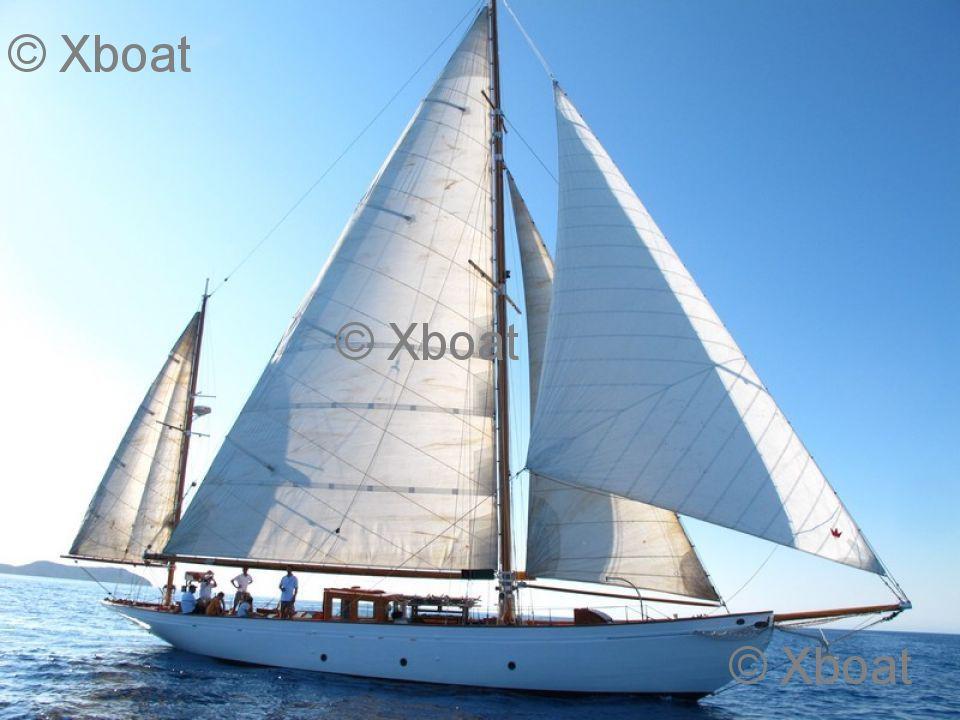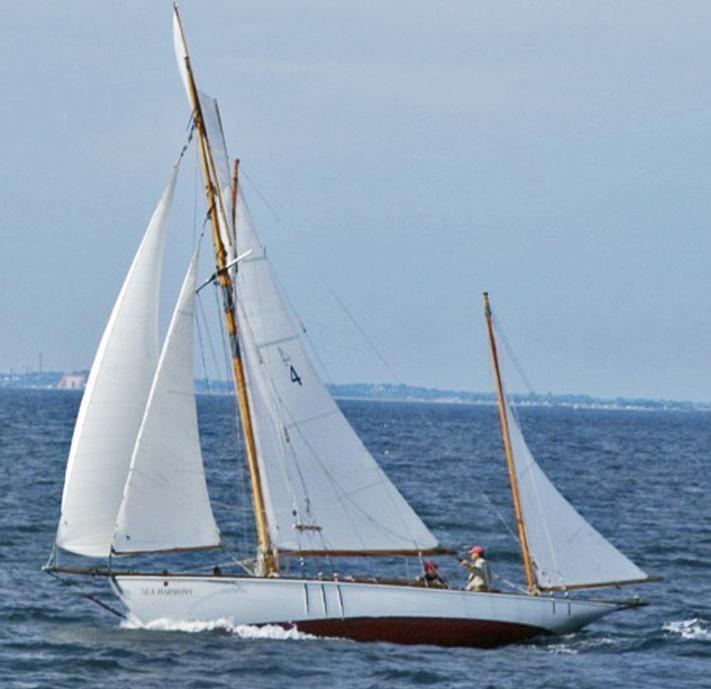The first image is the image on the left, the second image is the image on the right. For the images shown, is this caption "There are exactly four visible sails in the image on the left." true? Answer yes or no. Yes. 